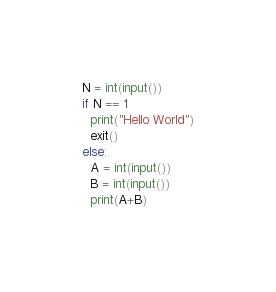Convert code to text. <code><loc_0><loc_0><loc_500><loc_500><_Python_>N = int(input())
if N == 1
  print("Hello World")
  exit()
else:
  A = int(input())
  B = int(input())
  print(A+B)</code> 